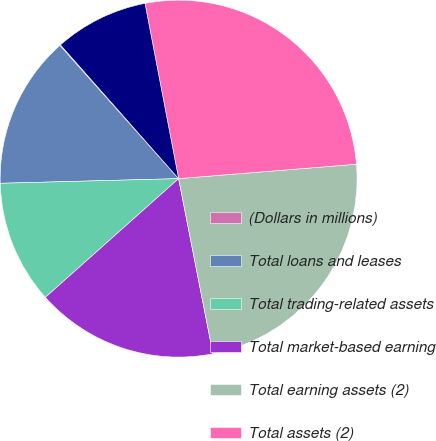Convert chart to OTSL. <chart><loc_0><loc_0><loc_500><loc_500><pie_chart><fcel>(Dollars in millions)<fcel>Total loans and leases<fcel>Total trading-related assets<fcel>Total market-based earning<fcel>Total earning assets (2)<fcel>Total assets (2)<fcel>Total deposits<nl><fcel>0.07%<fcel>13.83%<fcel>11.17%<fcel>16.5%<fcel>23.2%<fcel>26.73%<fcel>8.5%<nl></chart> 